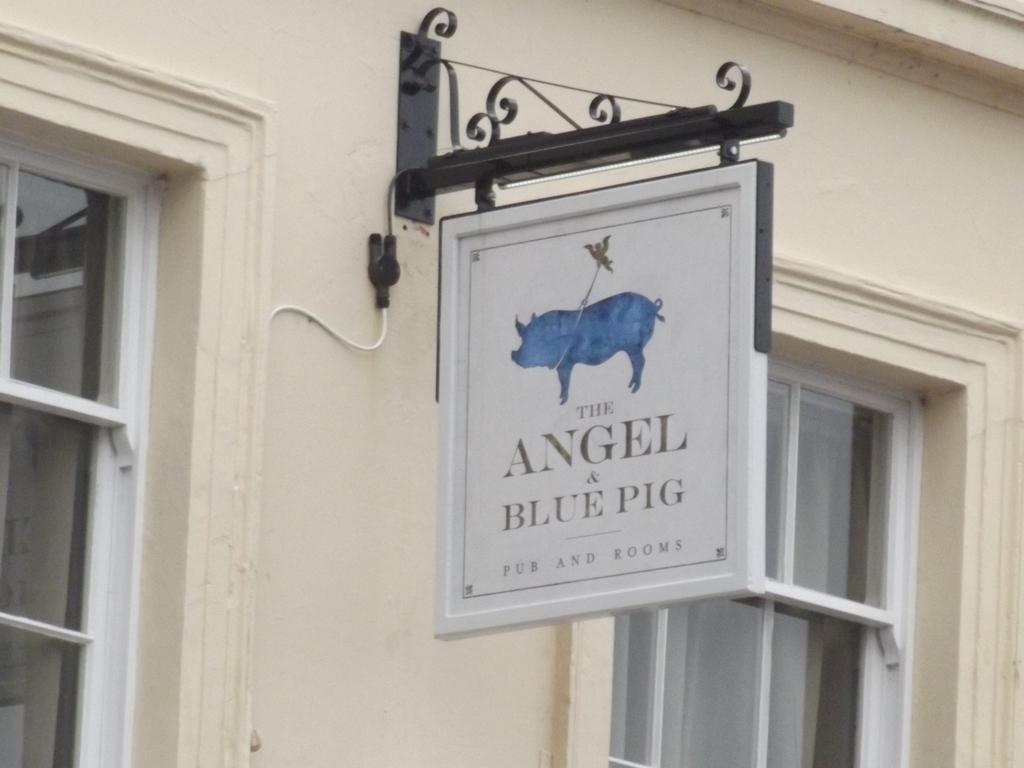Can you describe this image briefly? This is a wall with the windows, this a board. 